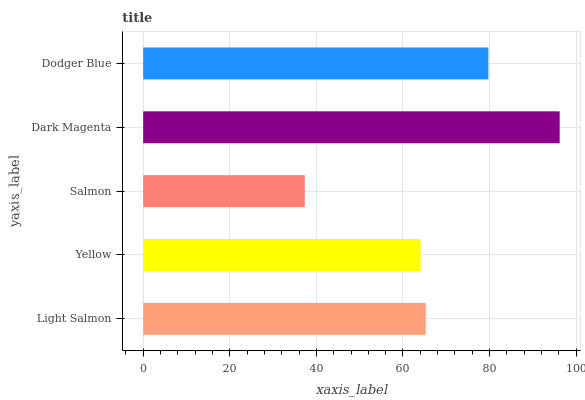Is Salmon the minimum?
Answer yes or no. Yes. Is Dark Magenta the maximum?
Answer yes or no. Yes. Is Yellow the minimum?
Answer yes or no. No. Is Yellow the maximum?
Answer yes or no. No. Is Light Salmon greater than Yellow?
Answer yes or no. Yes. Is Yellow less than Light Salmon?
Answer yes or no. Yes. Is Yellow greater than Light Salmon?
Answer yes or no. No. Is Light Salmon less than Yellow?
Answer yes or no. No. Is Light Salmon the high median?
Answer yes or no. Yes. Is Light Salmon the low median?
Answer yes or no. Yes. Is Dodger Blue the high median?
Answer yes or no. No. Is Salmon the low median?
Answer yes or no. No. 